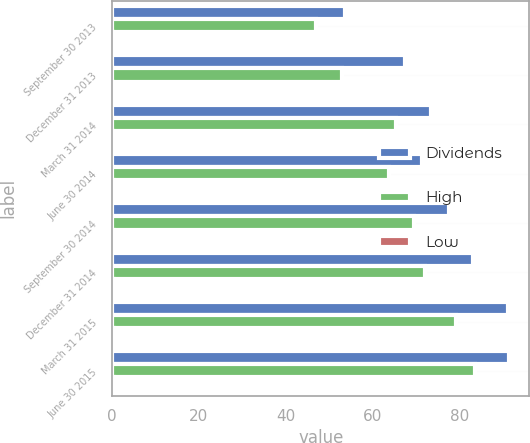<chart> <loc_0><loc_0><loc_500><loc_500><stacked_bar_chart><ecel><fcel>September 30 2013<fcel>December 31 2013<fcel>March 31 2014<fcel>June 30 2014<fcel>September 30 2014<fcel>December 31 2014<fcel>March 31 2015<fcel>June 30 2015<nl><fcel>Dividends<fcel>53.57<fcel>67.48<fcel>73.54<fcel>71.31<fcel>77.66<fcel>83.04<fcel>91.25<fcel>91.5<nl><fcel>High<fcel>47.02<fcel>52.95<fcel>65.26<fcel>63.8<fcel>69.59<fcel>72.13<fcel>79.19<fcel>83.65<nl><fcel>Low<fcel>0.3<fcel>0.3<fcel>0.3<fcel>0.34<fcel>0.34<fcel>0.34<fcel>0.34<fcel>0.39<nl></chart> 